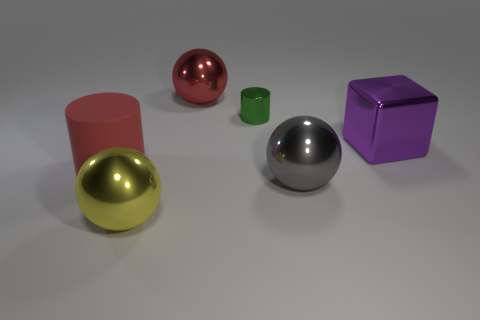The small cylinder that is made of the same material as the large gray sphere is what color?
Provide a succinct answer. Green. Are there more big metallic cubes than purple rubber cubes?
Provide a succinct answer. Yes. There is a object that is both in front of the large red ball and behind the purple metal cube; what size is it?
Offer a very short reply. Small. There is a large sphere that is the same color as the matte object; what is its material?
Keep it short and to the point. Metal. Is the number of green things in front of the big red ball the same as the number of big rubber cylinders?
Offer a very short reply. Yes. Is the size of the gray ball the same as the metal cylinder?
Keep it short and to the point. No. The large metallic object that is both right of the green metal cylinder and behind the big gray object is what color?
Offer a very short reply. Purple. What material is the large red object that is on the left side of the red object behind the matte object?
Ensure brevity in your answer.  Rubber. There is another object that is the same shape as the red matte object; what size is it?
Ensure brevity in your answer.  Small. Do the metallic ball behind the rubber thing and the large rubber object have the same color?
Ensure brevity in your answer.  Yes. 